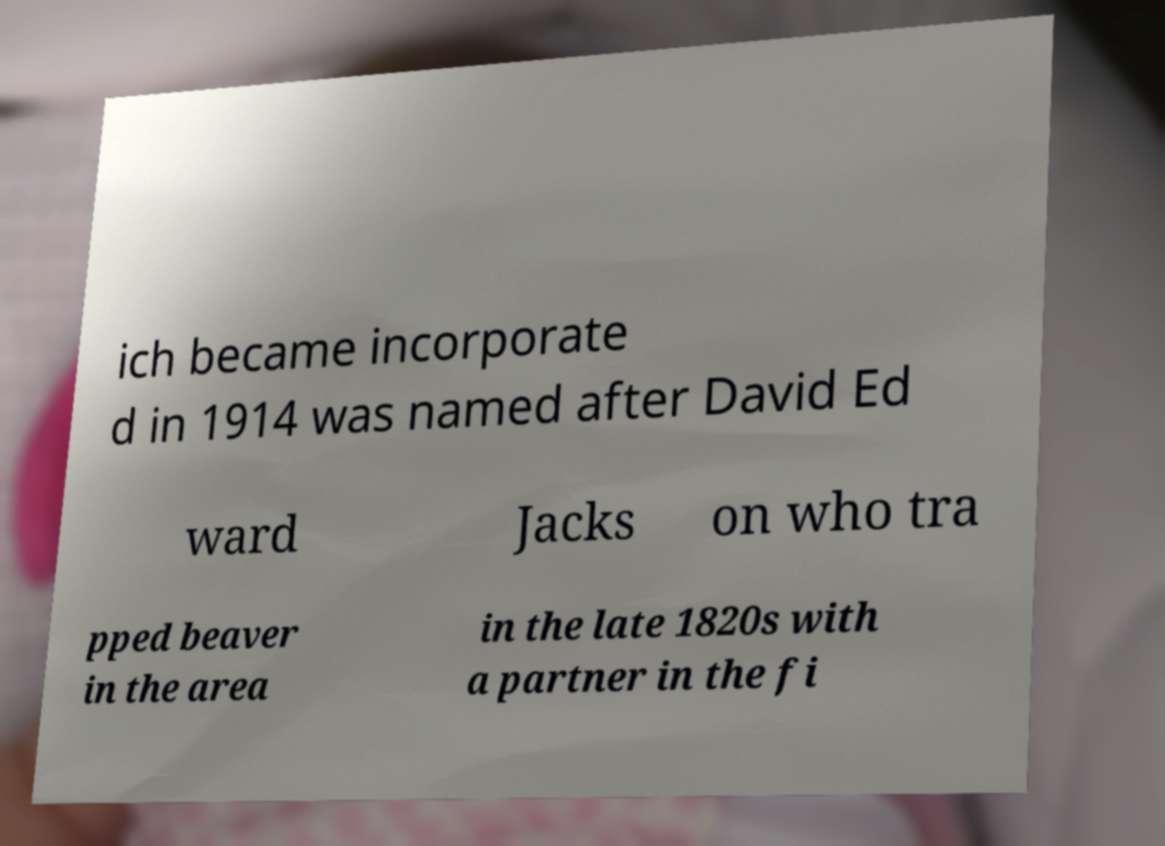Could you assist in decoding the text presented in this image and type it out clearly? ich became incorporate d in 1914 was named after David Ed ward Jacks on who tra pped beaver in the area in the late 1820s with a partner in the fi 